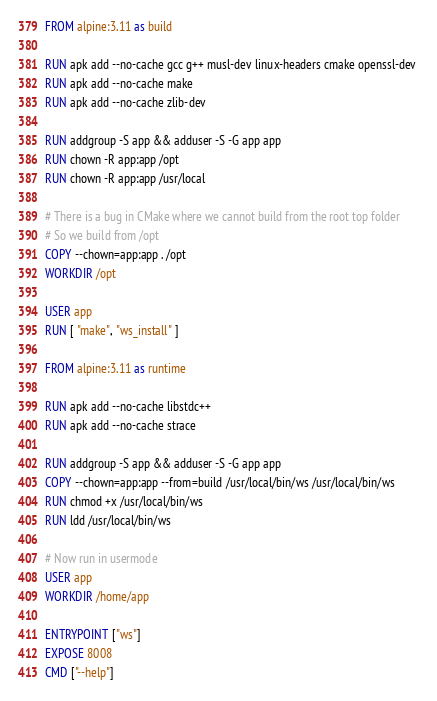Convert code to text. <code><loc_0><loc_0><loc_500><loc_500><_Dockerfile_>FROM alpine:3.11 as build

RUN apk add --no-cache gcc g++ musl-dev linux-headers cmake openssl-dev 
RUN apk add --no-cache make
RUN apk add --no-cache zlib-dev

RUN addgroup -S app && adduser -S -G app app 
RUN chown -R app:app /opt
RUN chown -R app:app /usr/local

# There is a bug in CMake where we cannot build from the root top folder
# So we build from /opt
COPY --chown=app:app . /opt
WORKDIR /opt

USER app
RUN [ "make", "ws_install" ]

FROM alpine:3.11 as runtime

RUN apk add --no-cache libstdc++
RUN apk add --no-cache strace

RUN addgroup -S app && adduser -S -G app app 
COPY --chown=app:app --from=build /usr/local/bin/ws /usr/local/bin/ws
RUN chmod +x /usr/local/bin/ws
RUN ldd /usr/local/bin/ws

# Now run in usermode
USER app
WORKDIR /home/app

ENTRYPOINT ["ws"]
EXPOSE 8008
CMD ["--help"]
</code> 